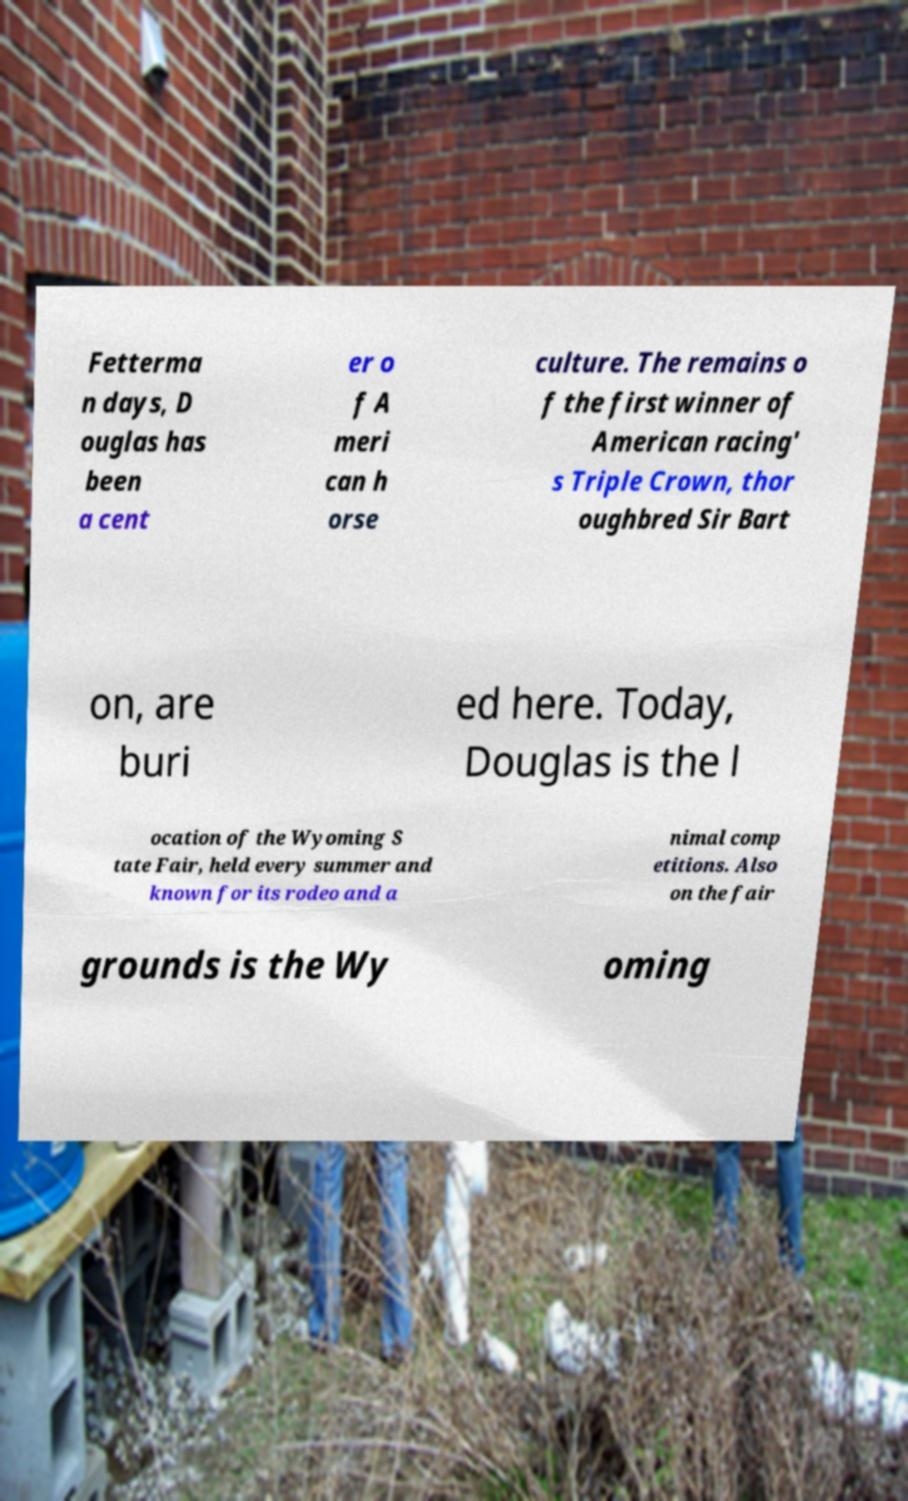Can you read and provide the text displayed in the image?This photo seems to have some interesting text. Can you extract and type it out for me? Fetterma n days, D ouglas has been a cent er o f A meri can h orse culture. The remains o f the first winner of American racing' s Triple Crown, thor oughbred Sir Bart on, are buri ed here. Today, Douglas is the l ocation of the Wyoming S tate Fair, held every summer and known for its rodeo and a nimal comp etitions. Also on the fair grounds is the Wy oming 